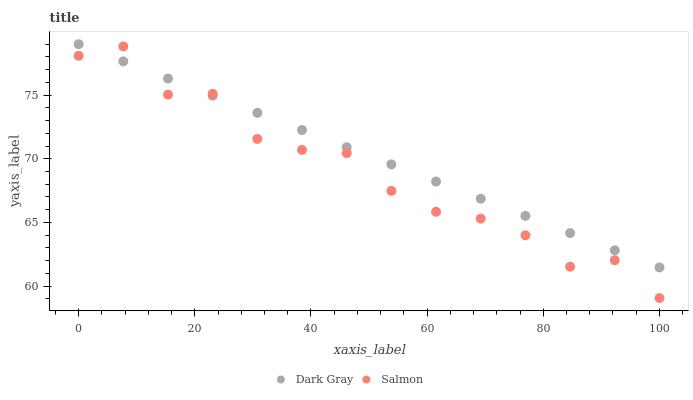Does Salmon have the minimum area under the curve?
Answer yes or no. Yes. Does Dark Gray have the maximum area under the curve?
Answer yes or no. Yes. Does Salmon have the maximum area under the curve?
Answer yes or no. No. Is Dark Gray the smoothest?
Answer yes or no. Yes. Is Salmon the roughest?
Answer yes or no. Yes. Is Salmon the smoothest?
Answer yes or no. No. Does Salmon have the lowest value?
Answer yes or no. Yes. Does Dark Gray have the highest value?
Answer yes or no. Yes. Does Salmon have the highest value?
Answer yes or no. No. Does Dark Gray intersect Salmon?
Answer yes or no. Yes. Is Dark Gray less than Salmon?
Answer yes or no. No. Is Dark Gray greater than Salmon?
Answer yes or no. No. 